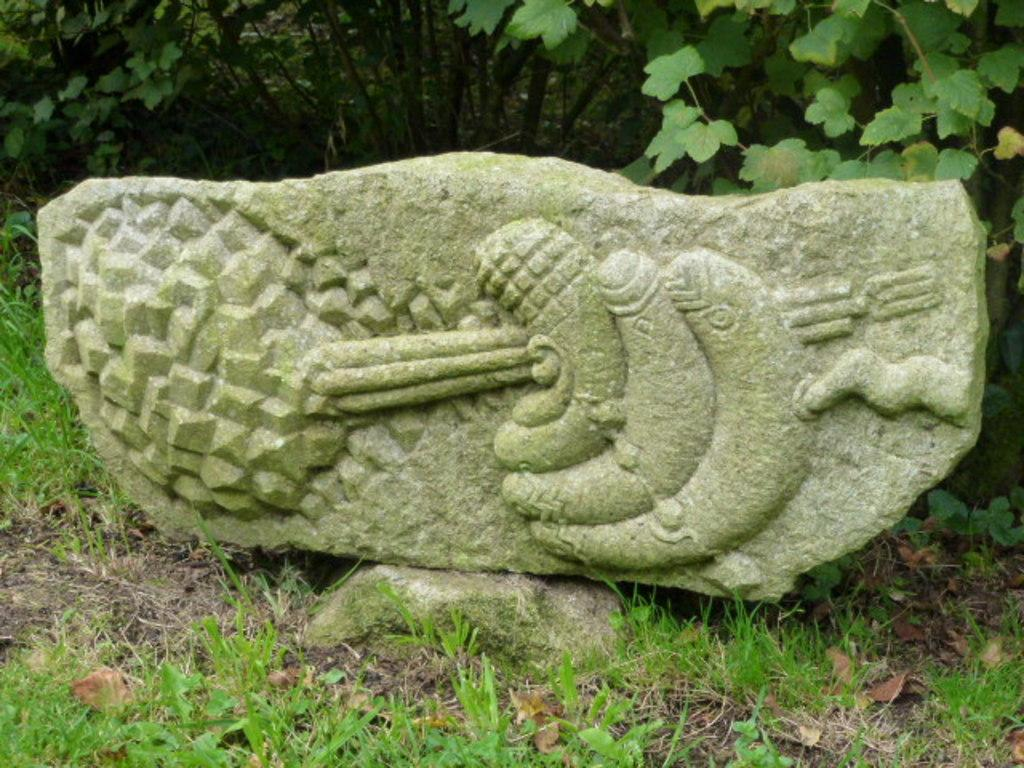What is the main object in the image? There is a stone in the image. What can be seen on the stone? There is a design on the stone. What type of vegetation is present in the image? The image contains grass and leaves. How many nerves can be seen in the image? There are no nerves visible in the image; it features a stone with a design and vegetation. What is the fifth element in the image? The facts provided do not mention a fifth element, and there are only four elements mentioned: stone, design, grass, and leaves. 